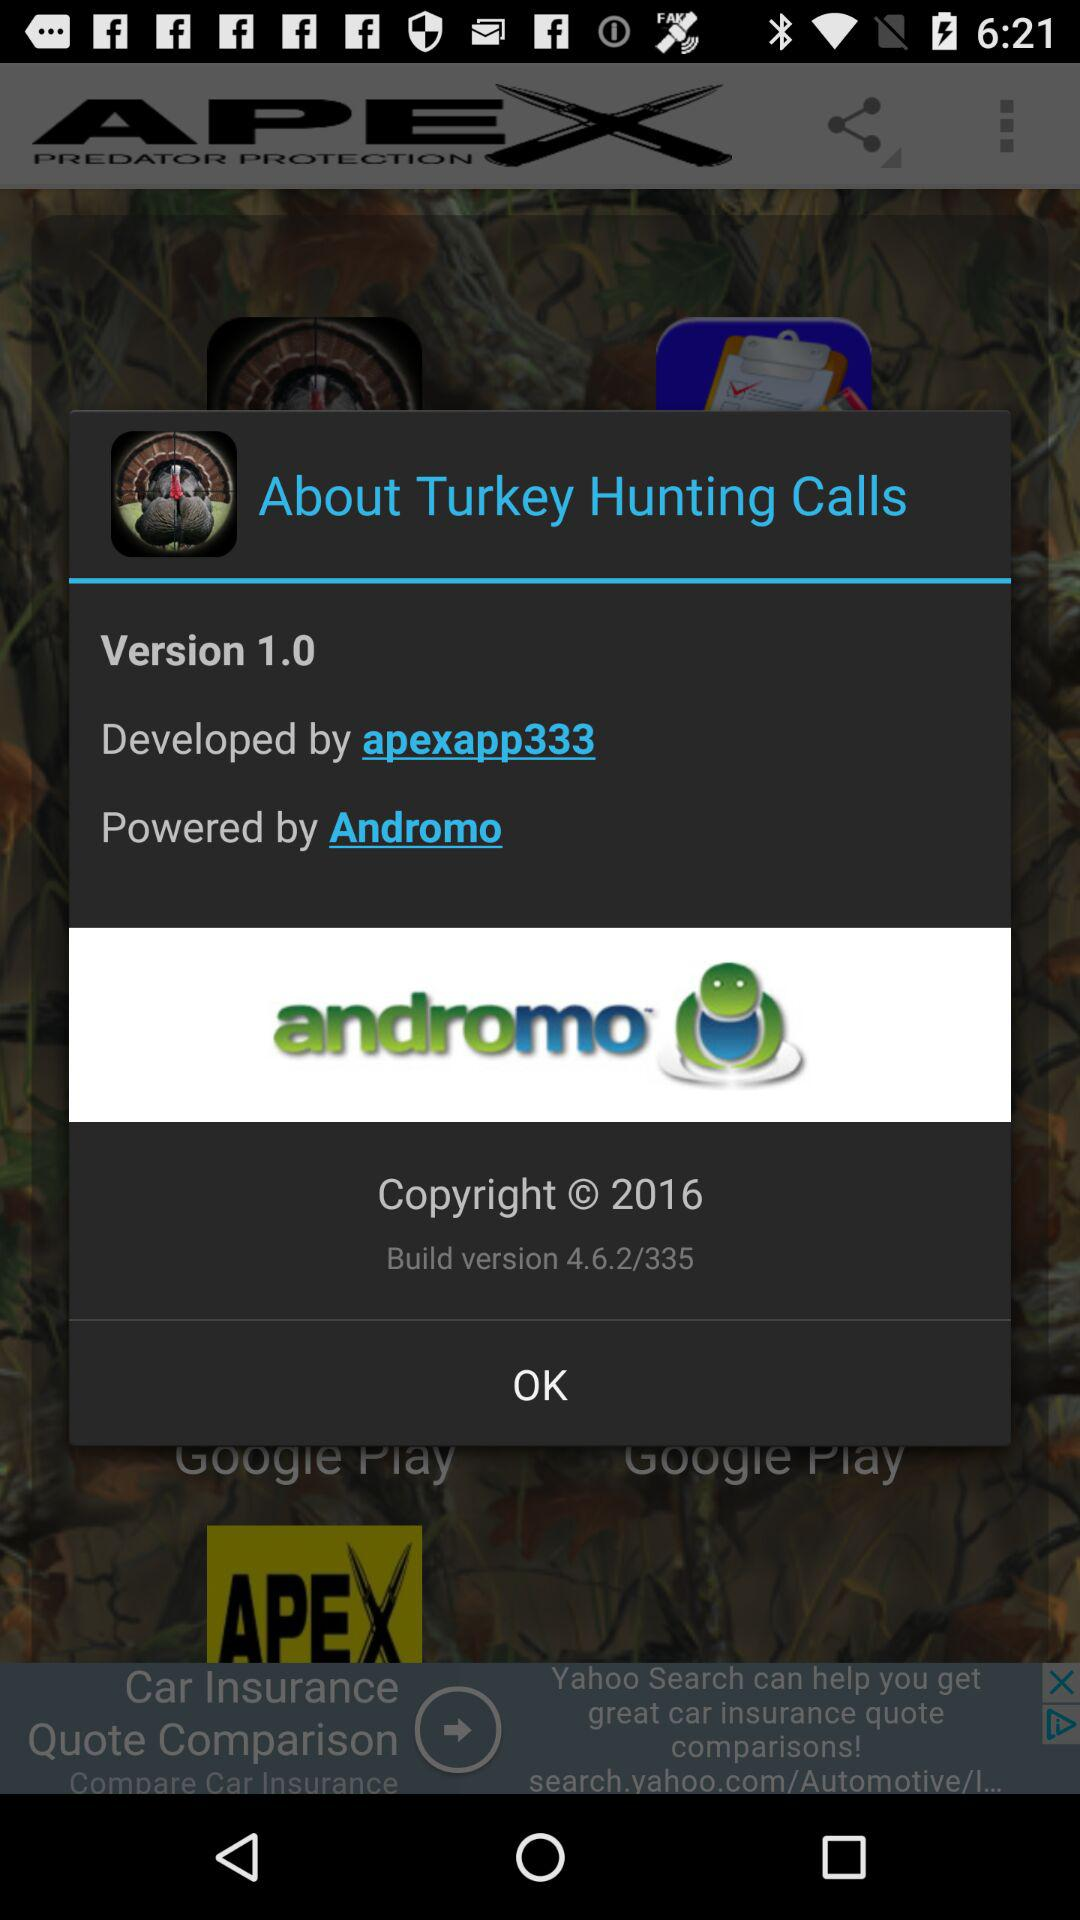By whom is "About Turkey Hunting Calls" powered? It is powered by "Andromo". 